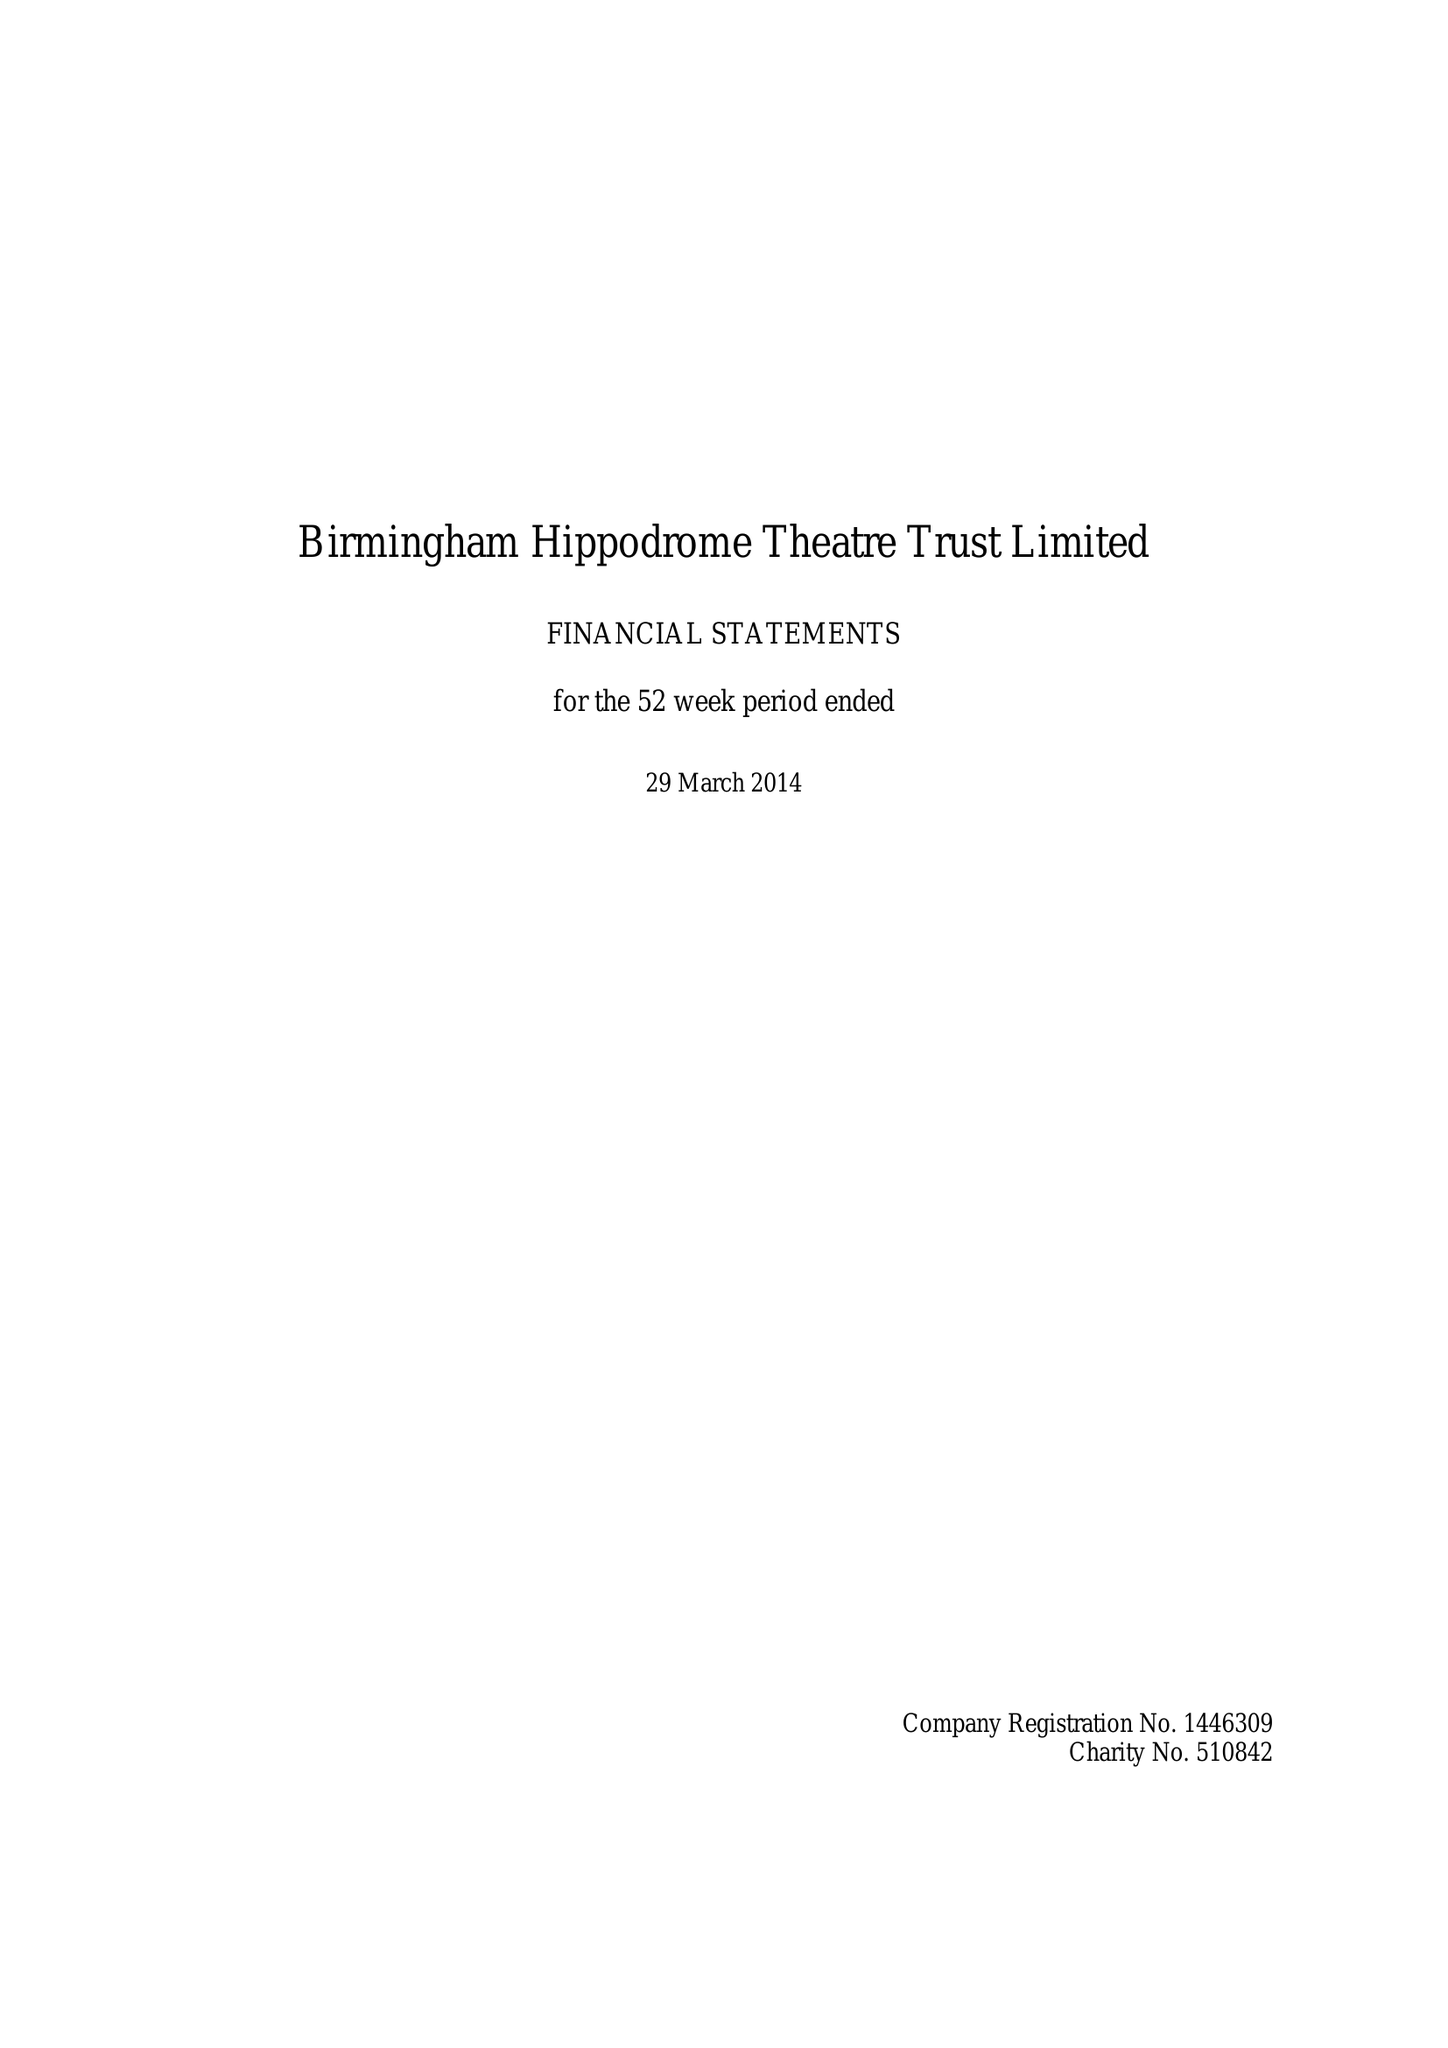What is the value for the report_date?
Answer the question using a single word or phrase. 2014-03-29 